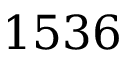Convert formula to latex. <formula><loc_0><loc_0><loc_500><loc_500>1 5 3 6</formula> 